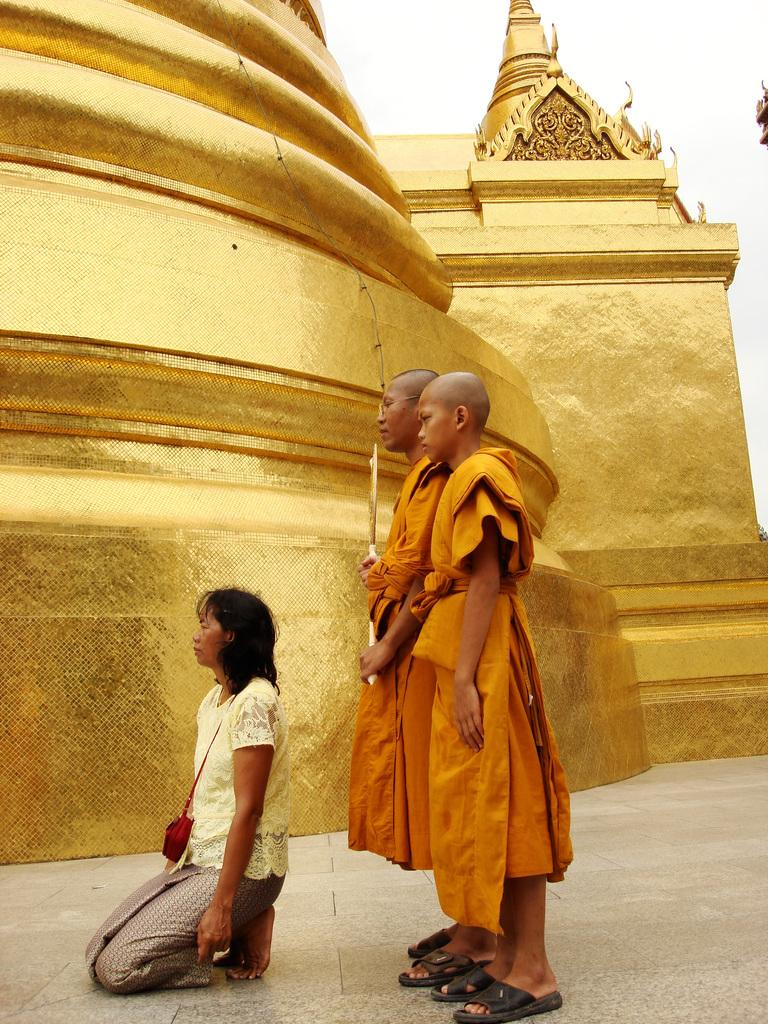How many people are present in the image? There are two people standing in the image. What is the woman in the image doing? The woman is sitting on her knees in the image. What is the woman holding in the image? The woman is holding a wire bag in the image. What can be seen in the background of the image? There is a gold wall and the sky visible in the background of the image. Can you see an aunt holding a zebra in the image? There is no aunt or zebra present in the image. 